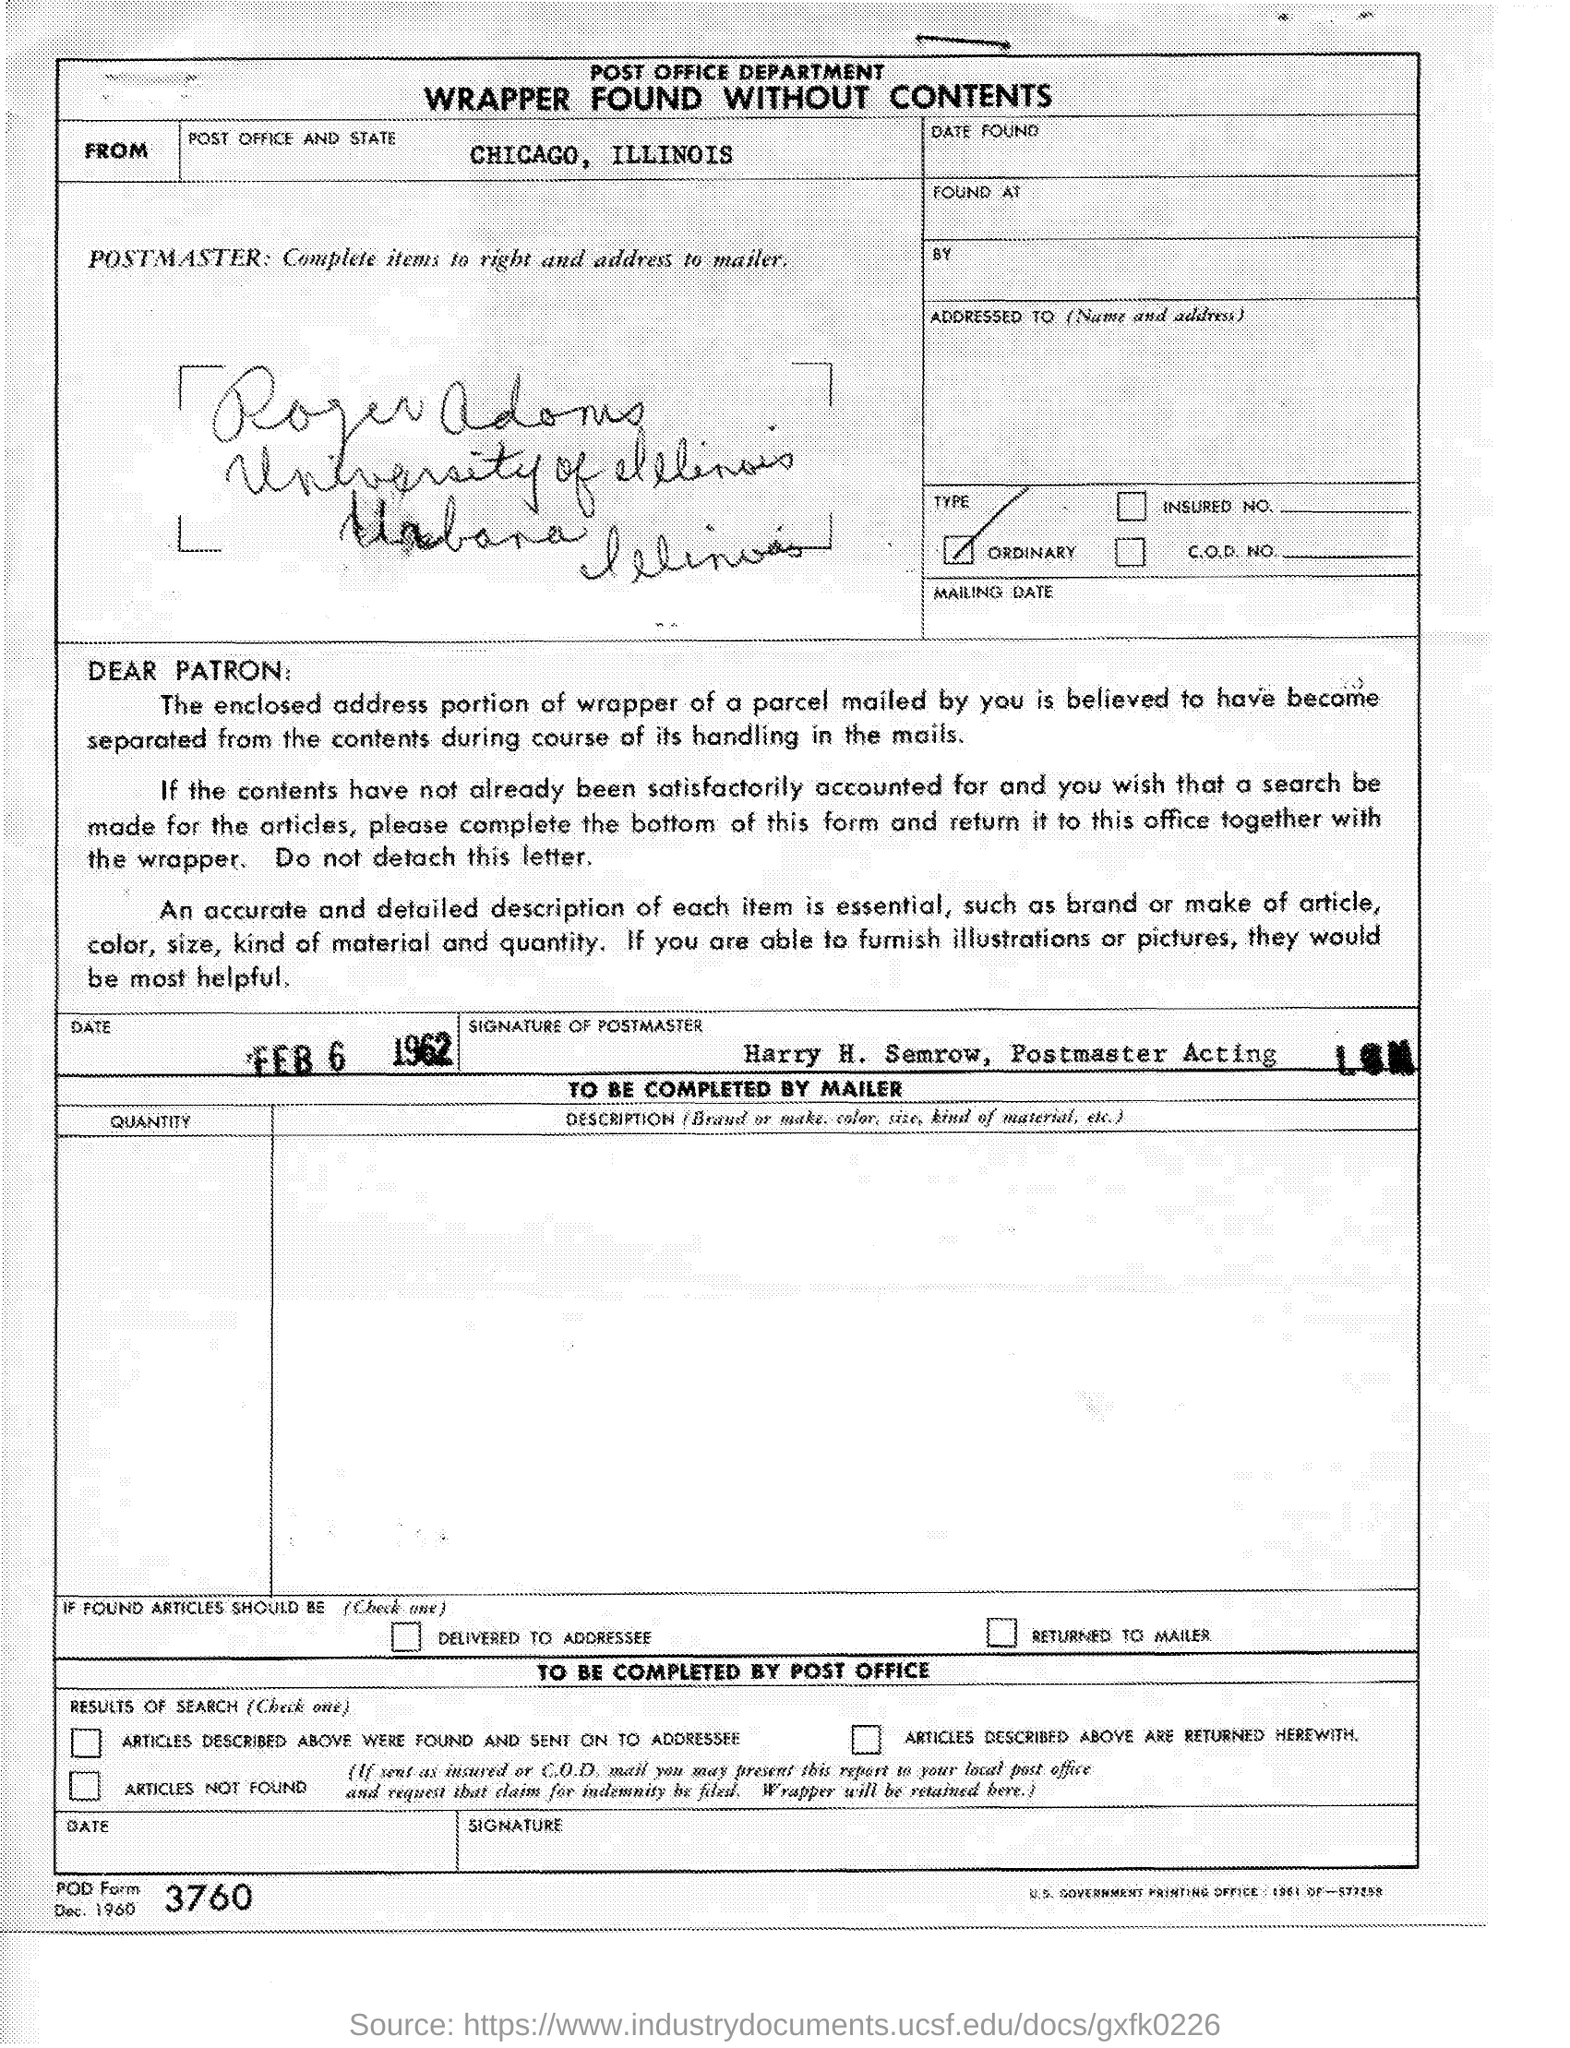What is the Post Office and state?
Offer a very short reply. Chicago, Illinois. What is the Date?
Provide a short and direct response. FEB 6 1962. 